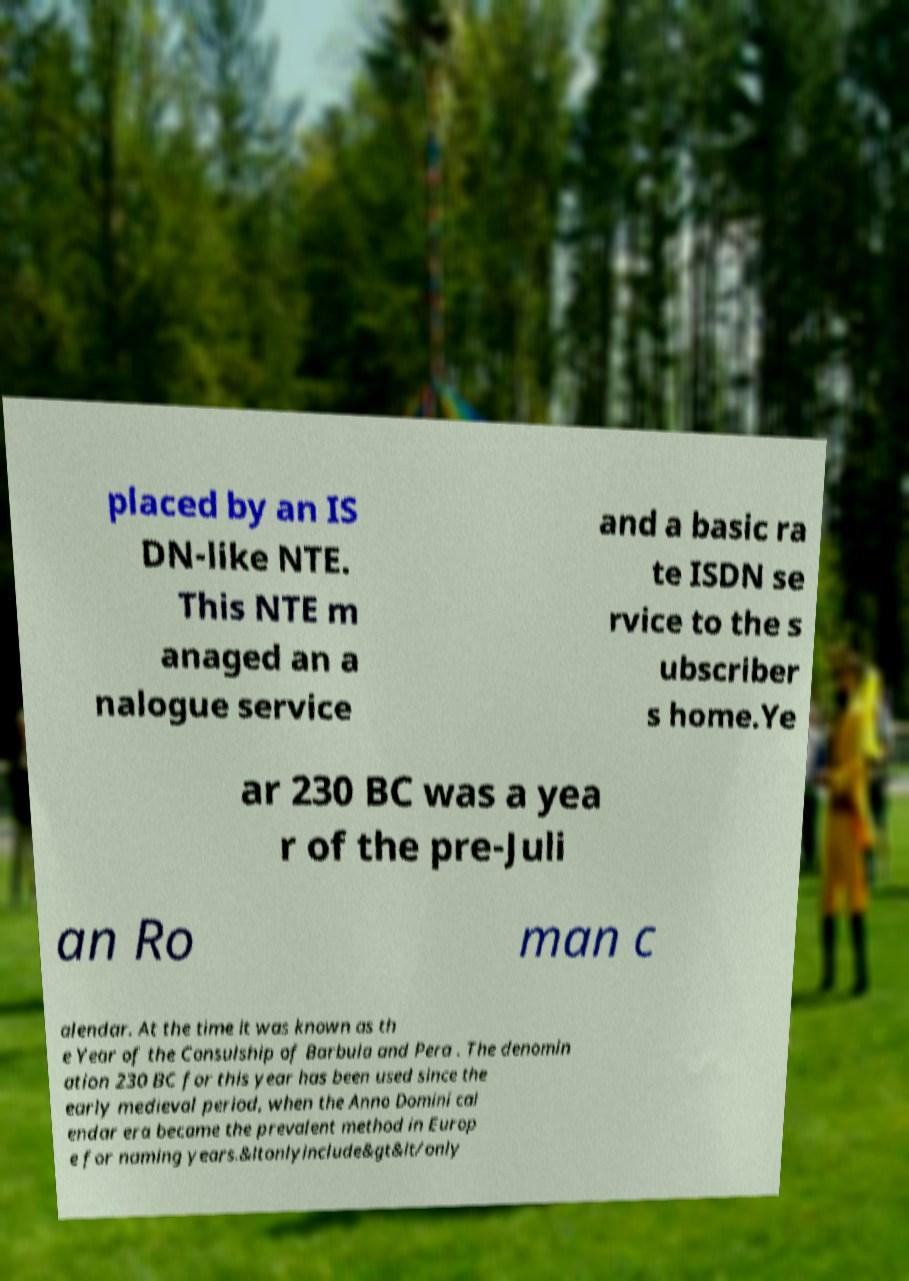I need the written content from this picture converted into text. Can you do that? placed by an IS DN-like NTE. This NTE m anaged an a nalogue service and a basic ra te ISDN se rvice to the s ubscriber s home.Ye ar 230 BC was a yea r of the pre-Juli an Ro man c alendar. At the time it was known as th e Year of the Consulship of Barbula and Pera . The denomin ation 230 BC for this year has been used since the early medieval period, when the Anno Domini cal endar era became the prevalent method in Europ e for naming years.&ltonlyinclude&gt&lt/only 